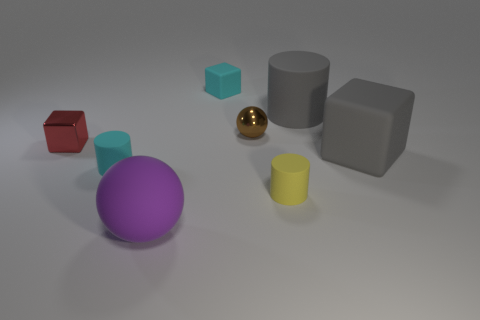What could be the function of these objects if they were real? If these objects existed in reality, they might serve as models for educational purposes to teach geometry or could be components in a child's building block set, designed to stimulate creativity and spatial reasoning.  Are these objects arranged in a specific pattern? There doesn't seem to be a deliberate pattern to their arrangement. The objects are placed somewhat randomly on the surface, which could suggest they're mid-use, like during play or demonstration, or they could simply be laid out without specific intent. 